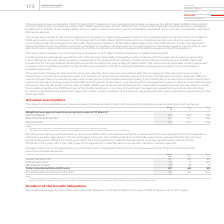From Vodafone Group Plc's financial document, Which financial items listed in the table are included within staff costs? The document contains multiple relevant values: Current service cost, Past service costs, Net interest charge. From the document: "2019 2018 2017 €m €m €m Current service cost 31 34 43 Past service costs 1 16 2 (27) Net interest charge 10 8 4 Total included within staff cost vice ..." Also, Which financial years' information is shown in the table? The document contains multiple relevant values: 2017, 2018, 2019. From the document: "h 2025 and made a cash contribution on 19 October 2017 of £185 million (€209 million) into the Vodafone Section and a further cash payment in accordan..." Also, How much is the 2019 current service cost? According to the financial document, 31 (in millions). The relevant text states: "2019 2018 2017 €m €m €m Current service cost 31 34 43 Past service costs 1 16 2 (27) Net interest charge 10 8 4 Total included within staff costs 5..." Also, can you calculate: What is the 2019 average actuarial losses recognised in the SOCI ? To answer this question, I need to perform calculations using the financial data. The calculation is: (33+94)/2, which equals 63.5 (in millions). This is based on the information: "44 20 Actuarial losses recognised in the SOCI 33 94 274 57 44 20 Actuarial losses recognised in the SOCI 33 94 274..." The key data points involved are: 33, 94. Also, can you calculate: What is the 2018 average actuarial losses recognised in the SOCI ? To answer this question, I need to perform calculations using the financial data. The calculation is: (94+274)/2, which equals 184 (in millions). This is based on the information: "44 20 Actuarial losses recognised in the SOCI 33 94 274 20 Actuarial losses recognised in the SOCI 33 94 274..." The key data points involved are: 274, 94. Also, can you calculate: What is the change between 2018 and 2019 average actuarial losses recognised in the SOCI? To answer this question, I need to perform calculations using the financial data. The calculation is: [(33+94)/2] - [(94+274)/2], which equals -120.5 (in millions). This is based on the information: "44 20 Actuarial losses recognised in the SOCI 33 94 274 20 Actuarial losses recognised in the SOCI 33 94 274 20 Actuarial losses recognised in the SOCI 33 94 274 57 44 20 Actuarial losses recognised i..." The key data points involved are: 274, 33, 94. 